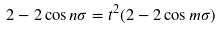Convert formula to latex. <formula><loc_0><loc_0><loc_500><loc_500>2 - 2 \cos n \sigma = t ^ { 2 } ( 2 - 2 \cos m \sigma )</formula> 